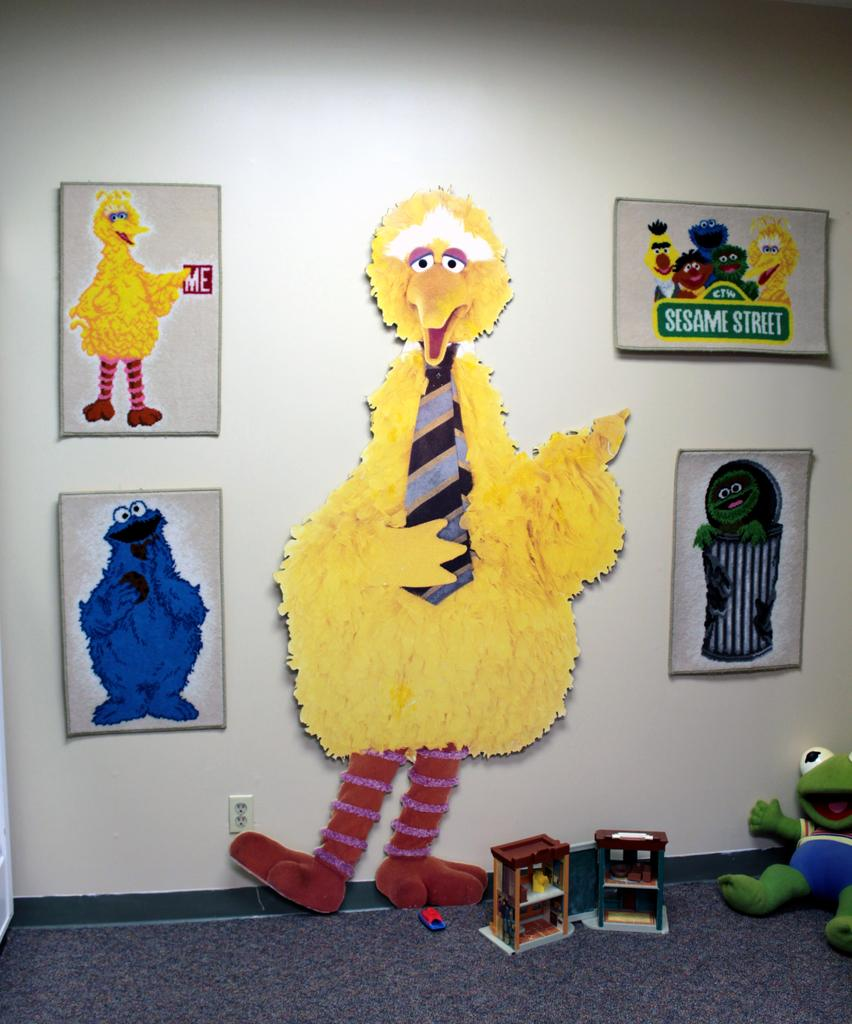What is present on the wall in the image? There are photo frames on the wall. What is depicted on the photo frames? There are cartoons on the photo frames. Is there anything else on the ground in the image besides the wall? Yes, there is a toy on the ground in the image. What type of friction can be observed between the toy and the ground in the image? There is no information about the toy's interaction with the ground in the image, so it is not possible to determine the type of friction. 